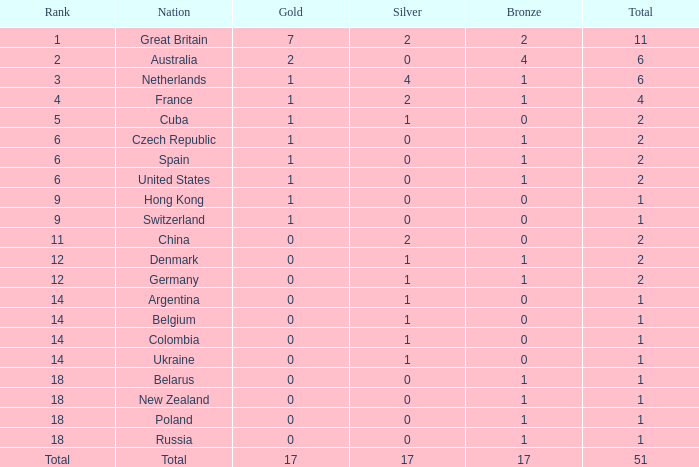Tell me the rank for bronze less than 17 and gold less than 1 11.0. 